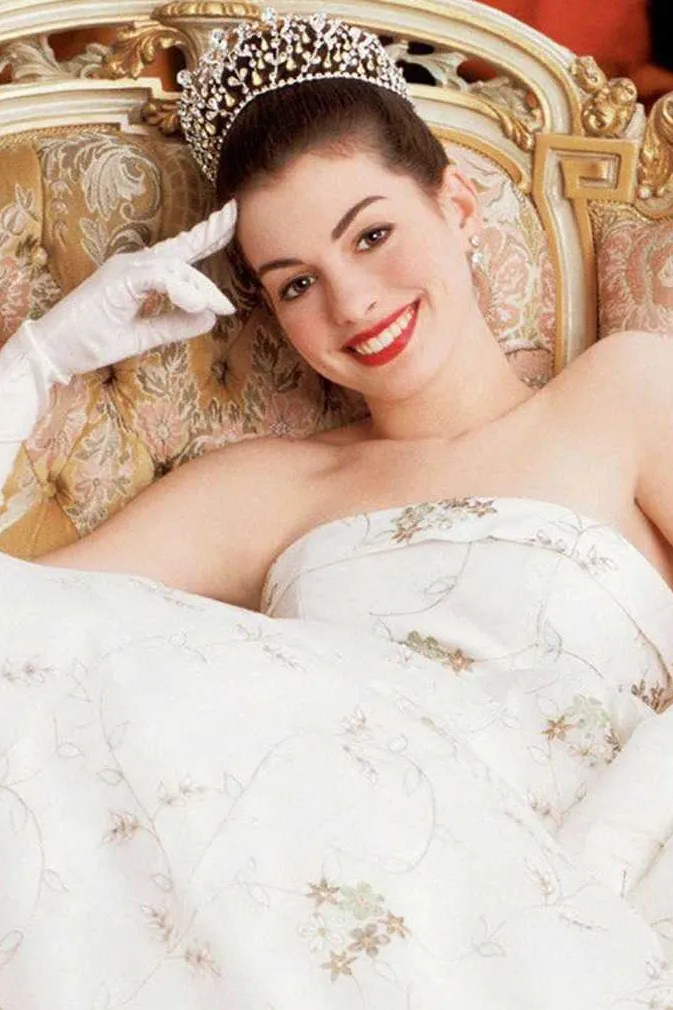Could you describe how the choice of apparel and accessories contributes to the character portrayal in the image? Certainly! The choice of a white strapless gown with floral embroidery imparts an elegant and pure aura, appropriate for a young, noble character perhaps undergoing a significant transformation or celebration. The diamond tiara not only complements her regal appearance but also accentuates her importance in the setting, possibly highlighting her as a central figure. Additionally, the white gloves she wears are traditionally associated with formal attire and decorum, reinforcing her refined and dignified role within the narrative. 